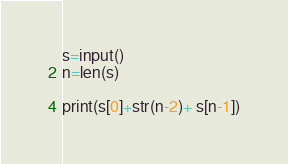Convert code to text. <code><loc_0><loc_0><loc_500><loc_500><_Python_>s=input()
n=len(s)

print(s[0]+str(n-2)+ s[n-1])
</code> 